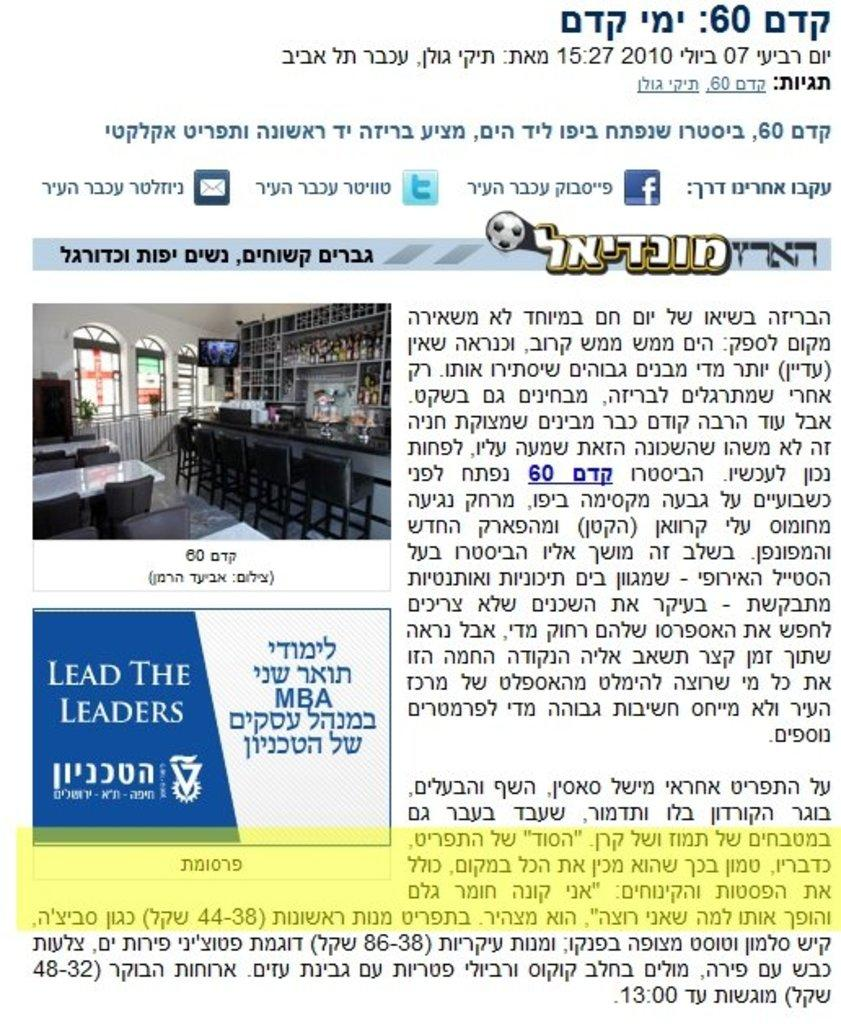<image>
Write a terse but informative summary of the picture. A flyer written in Arabic and words that read Lead the Leaders on it. 